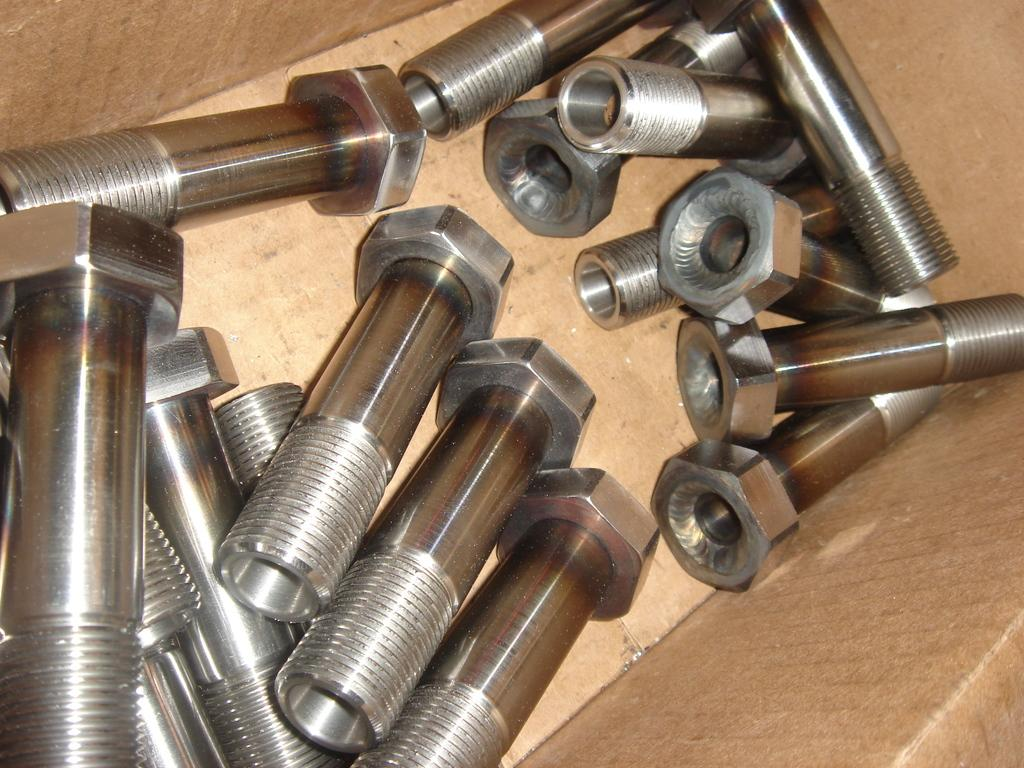What objects can be seen in the image? There are bolts in the image. Where are the bolts located? The bolts are in a box. What type of beam is being used to start a fire in the image? There is no beam or fire present in the image; it only features bolts in a box. 